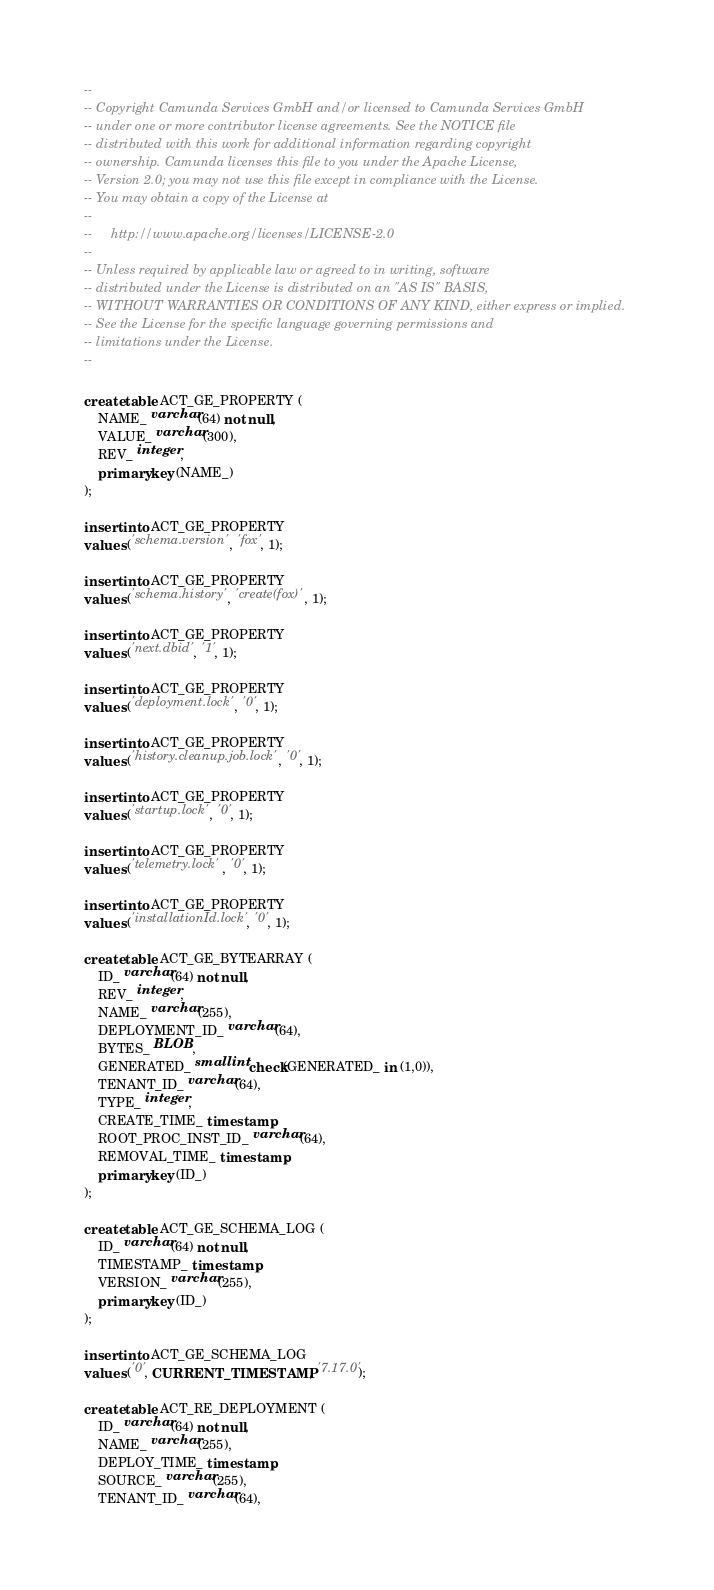Convert code to text. <code><loc_0><loc_0><loc_500><loc_500><_SQL_>--
-- Copyright Camunda Services GmbH and/or licensed to Camunda Services GmbH
-- under one or more contributor license agreements. See the NOTICE file
-- distributed with this work for additional information regarding copyright
-- ownership. Camunda licenses this file to you under the Apache License,
-- Version 2.0; you may not use this file except in compliance with the License.
-- You may obtain a copy of the License at
--
--     http://www.apache.org/licenses/LICENSE-2.0
--
-- Unless required by applicable law or agreed to in writing, software
-- distributed under the License is distributed on an "AS IS" BASIS,
-- WITHOUT WARRANTIES OR CONDITIONS OF ANY KIND, either express or implied.
-- See the License for the specific language governing permissions and
-- limitations under the License.
--

create table ACT_GE_PROPERTY (
    NAME_ varchar(64) not null,
    VALUE_ varchar(300),
    REV_ integer,
    primary key (NAME_)
);

insert into ACT_GE_PROPERTY
values ('schema.version', 'fox', 1);

insert into ACT_GE_PROPERTY
values ('schema.history', 'create(fox)', 1);

insert into ACT_GE_PROPERTY
values ('next.dbid', '1', 1);

insert into ACT_GE_PROPERTY
values ('deployment.lock', '0', 1);

insert into ACT_GE_PROPERTY
values ('history.cleanup.job.lock', '0', 1);

insert into ACT_GE_PROPERTY
values ('startup.lock', '0', 1);

insert into ACT_GE_PROPERTY
values ('telemetry.lock', '0', 1);

insert into ACT_GE_PROPERTY
values ('installationId.lock', '0', 1);

create table ACT_GE_BYTEARRAY (
    ID_ varchar(64) not null,
    REV_ integer,
    NAME_ varchar(255),
    DEPLOYMENT_ID_ varchar(64),
    BYTES_ BLOB,
    GENERATED_ smallint check(GENERATED_ in (1,0)),
    TENANT_ID_ varchar(64),
    TYPE_ integer,
    CREATE_TIME_ timestamp,
    ROOT_PROC_INST_ID_ varchar(64),
    REMOVAL_TIME_ timestamp,
    primary key (ID_)
);

create table ACT_GE_SCHEMA_LOG (
    ID_ varchar(64) not null,
    TIMESTAMP_ timestamp,
    VERSION_ varchar(255),
    primary key (ID_)
);

insert into ACT_GE_SCHEMA_LOG
values ('0', CURRENT_TIMESTAMP, '7.17.0');

create table ACT_RE_DEPLOYMENT (
    ID_ varchar(64) not null,
    NAME_ varchar(255),
    DEPLOY_TIME_ timestamp,
    SOURCE_ varchar(255),
    TENANT_ID_ varchar(64),</code> 